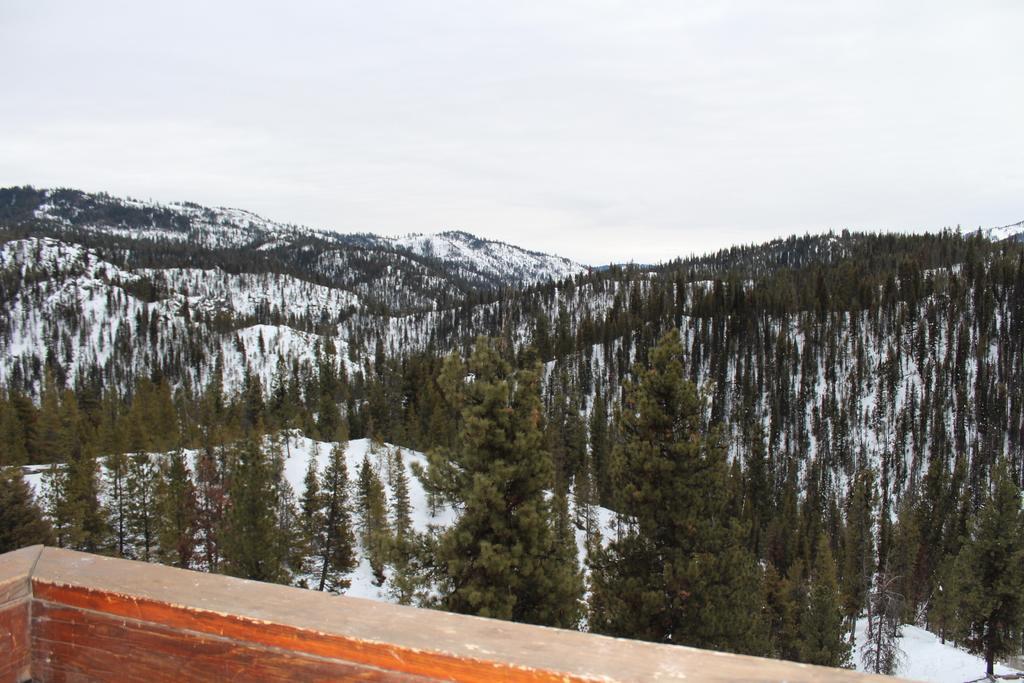Please provide a concise description of this image. In this image on the left side I can see the wall. In the background, I can see the hills covered with the trees and the snow. At the top I can see the sky. 